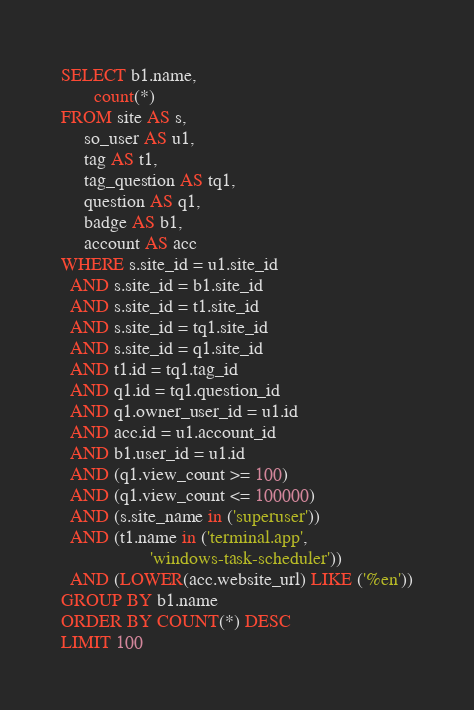<code> <loc_0><loc_0><loc_500><loc_500><_SQL_>SELECT b1.name,
       count(*)
FROM site AS s,
     so_user AS u1,
     tag AS t1,
     tag_question AS tq1,
     question AS q1,
     badge AS b1,
     account AS acc
WHERE s.site_id = u1.site_id
  AND s.site_id = b1.site_id
  AND s.site_id = t1.site_id
  AND s.site_id = tq1.site_id
  AND s.site_id = q1.site_id
  AND t1.id = tq1.tag_id
  AND q1.id = tq1.question_id
  AND q1.owner_user_id = u1.id
  AND acc.id = u1.account_id
  AND b1.user_id = u1.id
  AND (q1.view_count >= 100)
  AND (q1.view_count <= 100000)
  AND (s.site_name in ('superuser'))
  AND (t1.name in ('terminal.app',
                   'windows-task-scheduler'))
  AND (LOWER(acc.website_url) LIKE ('%en'))
GROUP BY b1.name
ORDER BY COUNT(*) DESC
LIMIT 100</code> 